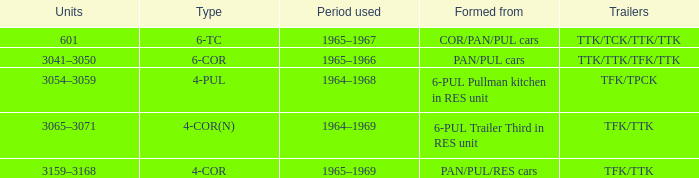Name the formed that has type of 4-cor PAN/PUL/RES cars. 